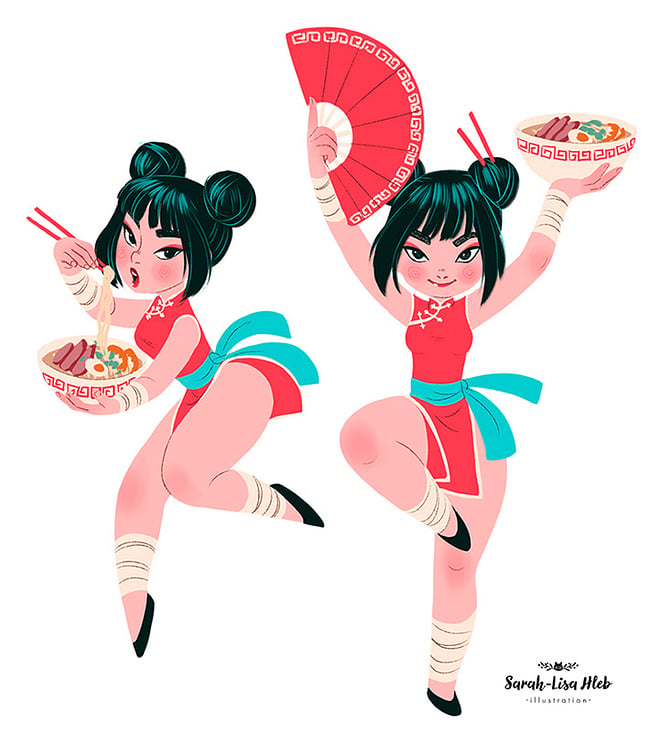Considering the styling and attire of the characters, what cultural fusion is represented through their costumes and props, and what does this suggest about the illustrator's intent or the context of the illustration? The illustrations vibrantly meld Asian and Western aesthetics. The characters are garbed in outfits that blend the iconic cheerleader look with traditional East Asian attire—highlighted by the use of chopsticks and a classic Asian fan. The choice of ramen, a quintessentially Asian comfort food, as well as the dynamic, almost athletic postures of the characters, bridges the gap between traditional Asian imagery and the high-energy, performance-driven spirit of Western cheerleading. This fusion likely aims to craft a playful yet respectful celebration of Asian culture within a modern, globalized context, appealing to a diverse audience and underscoring the universal appeal and adaptability of cultural elements. 